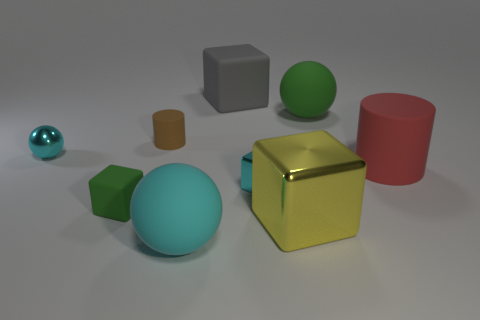Is there anything else that is the same color as the big metallic cube?
Make the answer very short. No. What is the shape of the large gray rubber thing?
Give a very brief answer. Cube. How many cylinders are either red things or brown rubber things?
Provide a short and direct response. 2. Are there an equal number of cylinders that are in front of the big yellow block and red things to the right of the large cylinder?
Give a very brief answer. Yes. There is a small cyan thing on the left side of the big ball that is to the left of the large yellow thing; what number of cyan objects are on the right side of it?
Your answer should be compact. 2. There is a small shiny object that is the same color as the tiny sphere; what is its shape?
Provide a short and direct response. Cube. Is the color of the large cylinder the same as the metal thing that is right of the small cyan metallic cube?
Provide a succinct answer. No. Is the number of cylinders that are behind the big gray cube greater than the number of cyan shiny objects?
Offer a terse response. No. How many things are rubber cylinders that are right of the brown rubber thing or spheres to the right of the cyan rubber object?
Keep it short and to the point. 2. There is a sphere that is the same material as the large yellow block; what size is it?
Give a very brief answer. Small. 